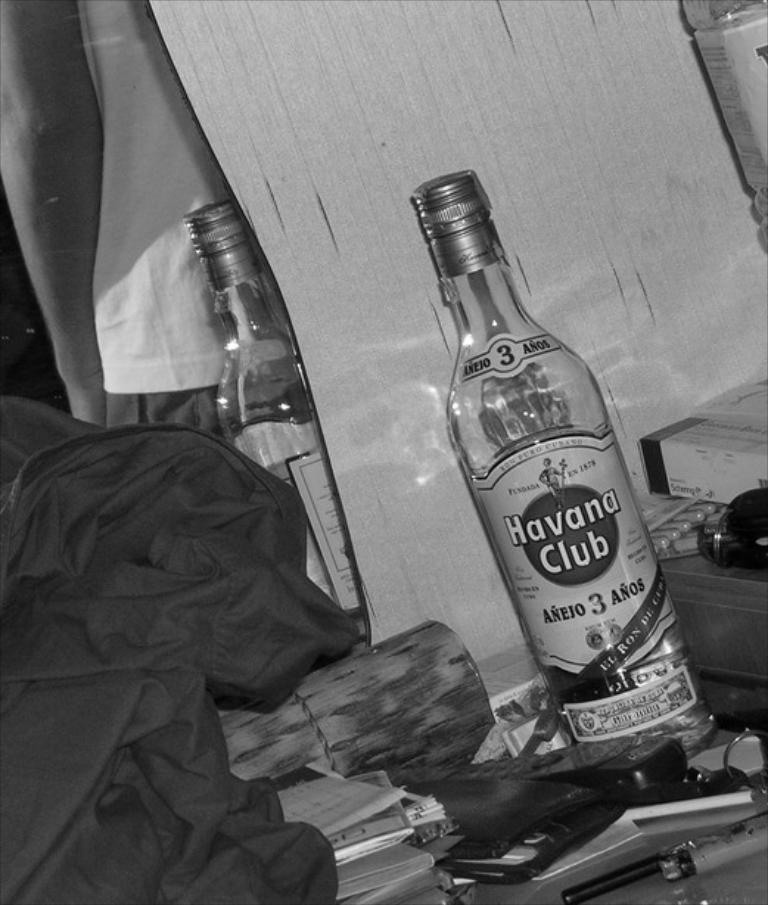What object can be seen in the image that might contain a liquid? There is a bottle in the image that might contain a liquid. What type of items are present in the image that might be related to learning or reading? There are books in the image that might be related to learning or reading. What object in the image might be used for making payments or storing money? There is a wallet in the image that might be used for making payments or storing money. What type of device is present in the image that allows for communication and connectivity? There is a mobile phone in the image that allows for communication and connectivity. What object in the image might be used for unlocking doors or starting vehicles? There are keys in the image that might be used for unlocking doors or starting vehicles. What type of clothing item is present in the image that might be worn for warmth or protection? There is a jacket in the image that might be worn for warmth or protection. What object in the image might be used for personal grooming or checking one's appearance? There is a mirror on the wall in the image that might be used for personal grooming or checking one's appearance. What is reflected in the mirror in the image? The mirror reflects a person and a bottle in the image. What type of weather can be seen in the image? There is no indication of weather in the image. What type of sail can be seen in the image? There is no sail present in the image. 